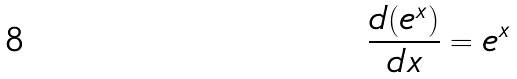<formula> <loc_0><loc_0><loc_500><loc_500>\frac { d ( e ^ { x } ) } { d x } = e ^ { x }</formula> 